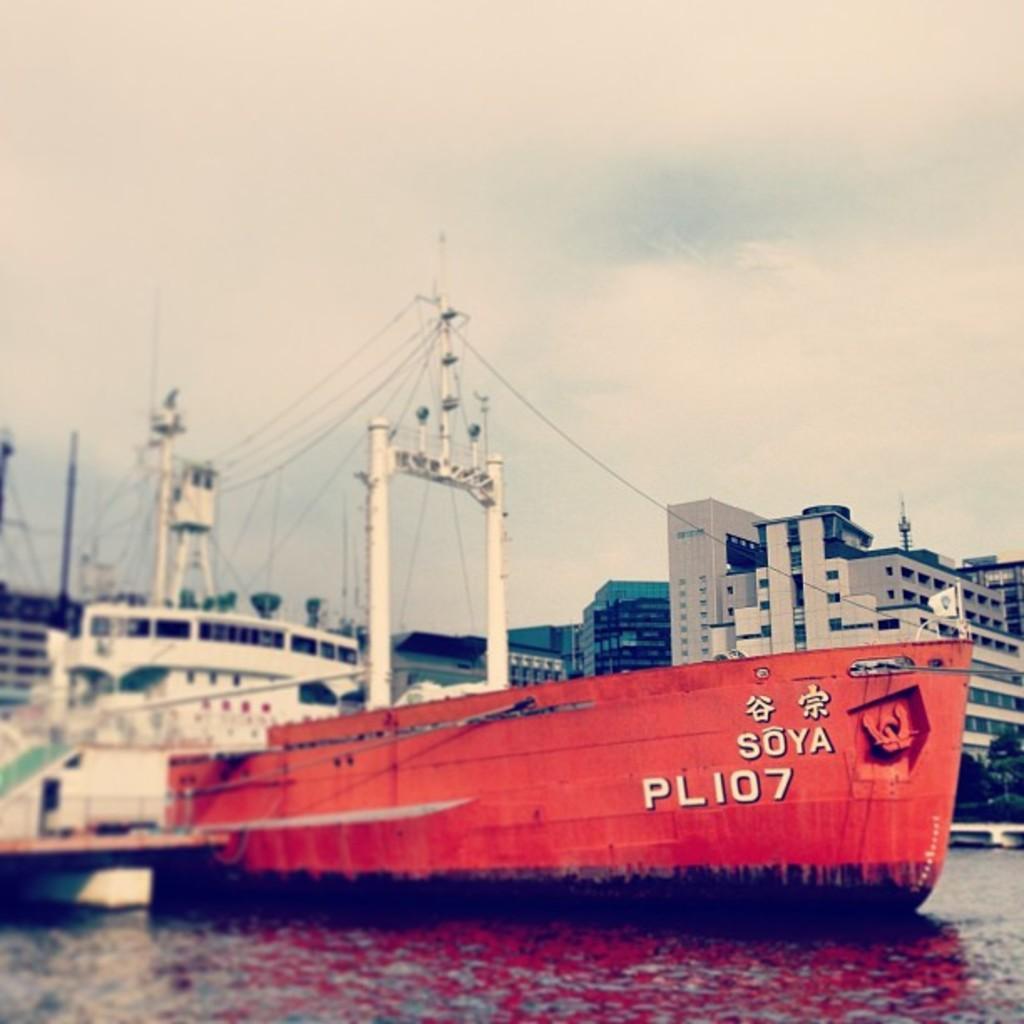Can you describe this image briefly? In the background we can see the sky and buildings. In this picture we can see the ships, trees, water and few objects. 